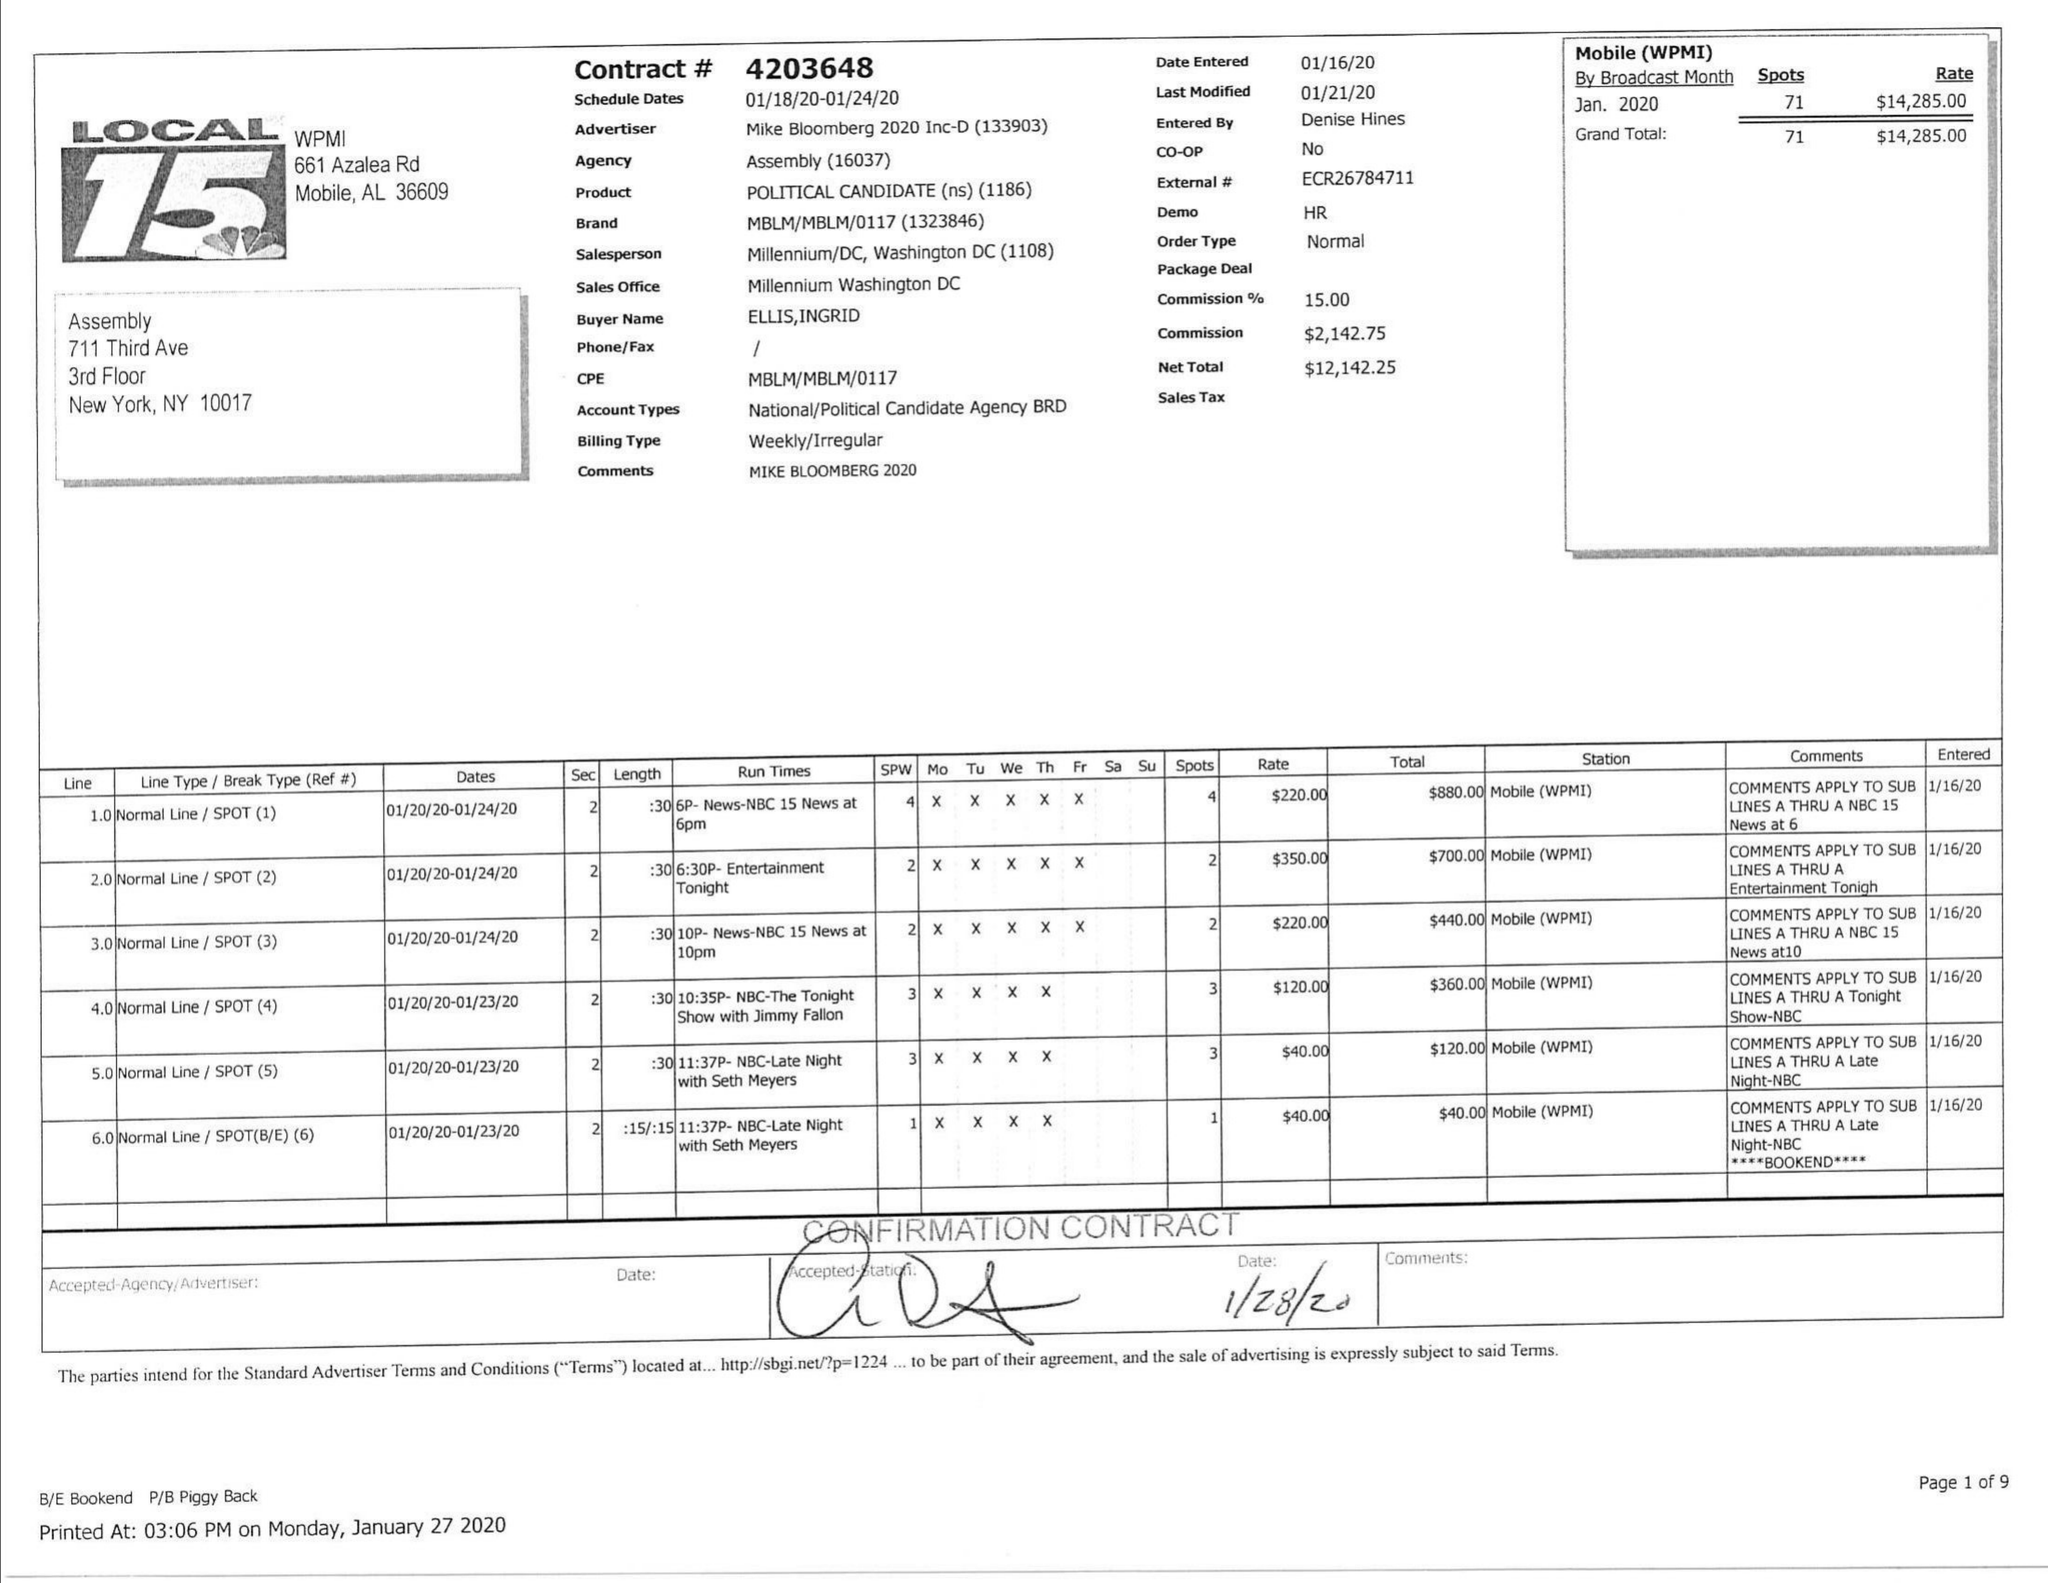What is the value for the contract_num?
Answer the question using a single word or phrase. 4203648 